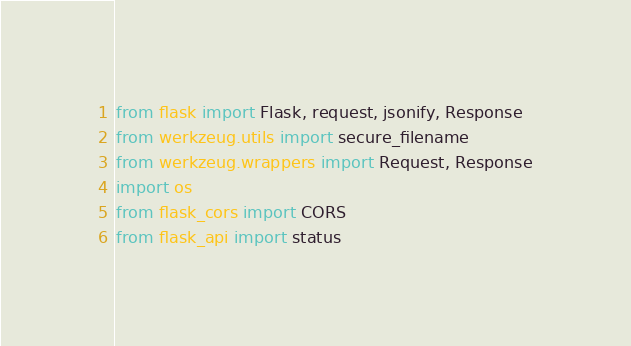Convert code to text. <code><loc_0><loc_0><loc_500><loc_500><_Python_>from flask import Flask, request, jsonify, Response
from werkzeug.utils import secure_filename
from werkzeug.wrappers import Request, Response
import os
from flask_cors import CORS
from flask_api import status</code> 